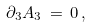<formula> <loc_0><loc_0><loc_500><loc_500>\partial _ { 3 } A _ { 3 } \, = \, 0 \, ,</formula> 